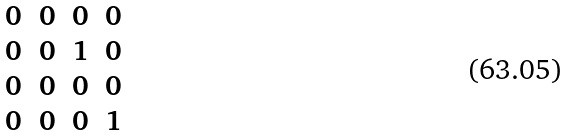Convert formula to latex. <formula><loc_0><loc_0><loc_500><loc_500>\begin{matrix} 0 & 0 & 0 & 0 \\ 0 & 0 & 1 & 0 \\ 0 & 0 & 0 & 0 \\ 0 & 0 & 0 & 1 \\ \end{matrix}</formula> 